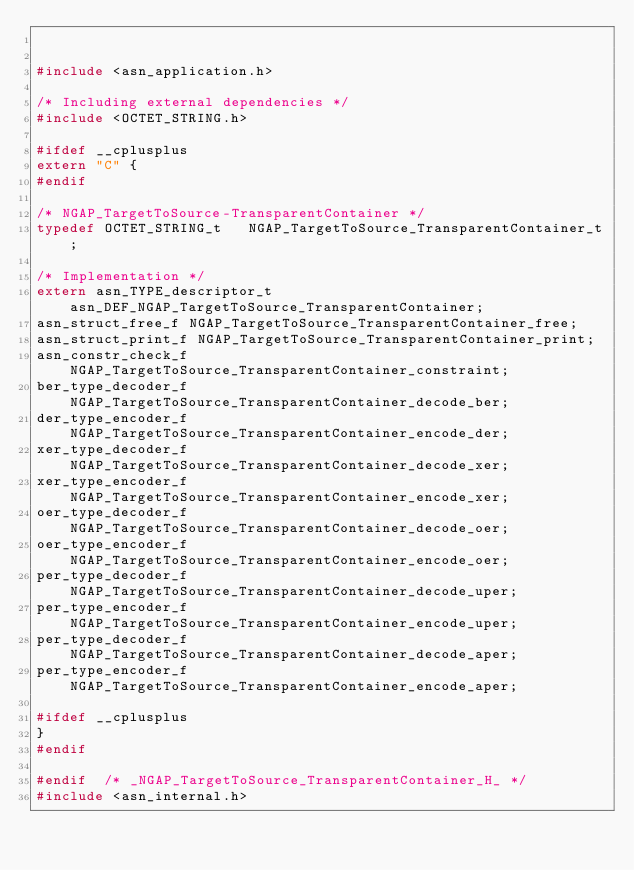Convert code to text. <code><loc_0><loc_0><loc_500><loc_500><_C_>

#include <asn_application.h>

/* Including external dependencies */
#include <OCTET_STRING.h>

#ifdef __cplusplus
extern "C" {
#endif

/* NGAP_TargetToSource-TransparentContainer */
typedef OCTET_STRING_t	 NGAP_TargetToSource_TransparentContainer_t;

/* Implementation */
extern asn_TYPE_descriptor_t asn_DEF_NGAP_TargetToSource_TransparentContainer;
asn_struct_free_f NGAP_TargetToSource_TransparentContainer_free;
asn_struct_print_f NGAP_TargetToSource_TransparentContainer_print;
asn_constr_check_f NGAP_TargetToSource_TransparentContainer_constraint;
ber_type_decoder_f NGAP_TargetToSource_TransparentContainer_decode_ber;
der_type_encoder_f NGAP_TargetToSource_TransparentContainer_encode_der;
xer_type_decoder_f NGAP_TargetToSource_TransparentContainer_decode_xer;
xer_type_encoder_f NGAP_TargetToSource_TransparentContainer_encode_xer;
oer_type_decoder_f NGAP_TargetToSource_TransparentContainer_decode_oer;
oer_type_encoder_f NGAP_TargetToSource_TransparentContainer_encode_oer;
per_type_decoder_f NGAP_TargetToSource_TransparentContainer_decode_uper;
per_type_encoder_f NGAP_TargetToSource_TransparentContainer_encode_uper;
per_type_decoder_f NGAP_TargetToSource_TransparentContainer_decode_aper;
per_type_encoder_f NGAP_TargetToSource_TransparentContainer_encode_aper;

#ifdef __cplusplus
}
#endif

#endif	/* _NGAP_TargetToSource_TransparentContainer_H_ */
#include <asn_internal.h>
</code> 